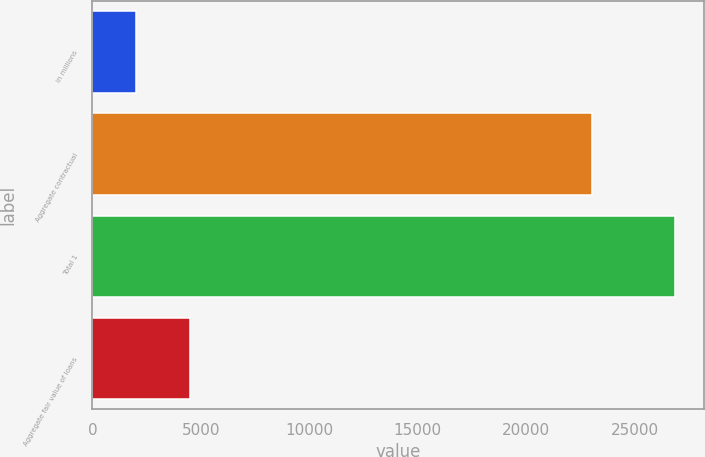Convert chart to OTSL. <chart><loc_0><loc_0><loc_500><loc_500><bar_chart><fcel>in millions<fcel>Aggregate contractual<fcel>Total 1<fcel>Aggregate fair value of loans<nl><fcel>2011<fcel>23034<fcel>26860<fcel>4495.9<nl></chart> 